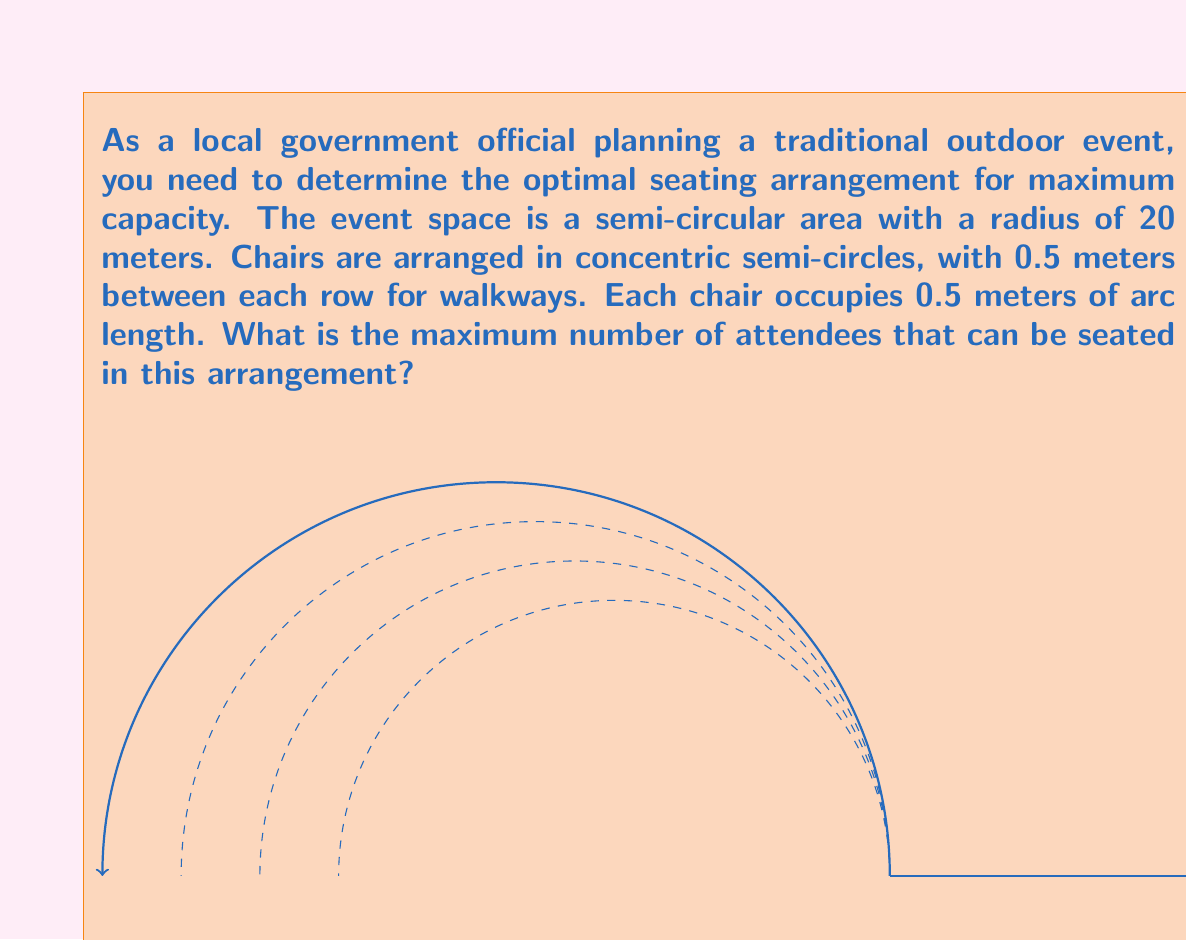Can you solve this math problem? Let's approach this step-by-step:

1) First, we need to determine how many rows of chairs we can fit:
   - The radius is 20 meters
   - Each row takes up 0.5 meters (chair) + 0.5 meters (walkway) = 1 meter
   - Number of rows = $\lfloor 20 \div 1 \rfloor = 20$ rows

2) Now, we need to calculate the number of chairs in each row:
   - The formula for arc length is $L = r\theta$, where $r$ is radius and $\theta$ is angle in radians
   - For a semicircle, $\theta = \pi$ radians
   - Each chair occupies 0.5 meters of arc length

3) For each row $i$ (counting from the outside in), where $i$ goes from 1 to 20:
   - Radius of row $i$: $r_i = 20 - i + 1$ (meters)
   - Arc length of row $i$: $L_i = r_i\pi$ (meters)
   - Number of chairs in row $i$: $N_i = \lfloor \frac{L_i}{0.5} \rfloor = \lfloor 2r_i\pi \rfloor$

4) Total number of chairs is the sum of chairs in all rows:

   $$\text{Total chairs} = \sum_{i=1}^{20} \lfloor 2(21-i)\pi \rfloor$$

5) Calculating this sum:
   
   $\lfloor 40\pi \rfloor + \lfloor 38\pi \rfloor + \lfloor 36\pi \rfloor + ... + \lfloor 4\pi \rfloor + \lfloor 2\pi \rfloor$
   
   $= 125 + 119 + 113 + ... + 12 + 6$
   
   $= 1310$

Therefore, the maximum number of attendees that can be seated is 1310.
Answer: 1310 attendees 